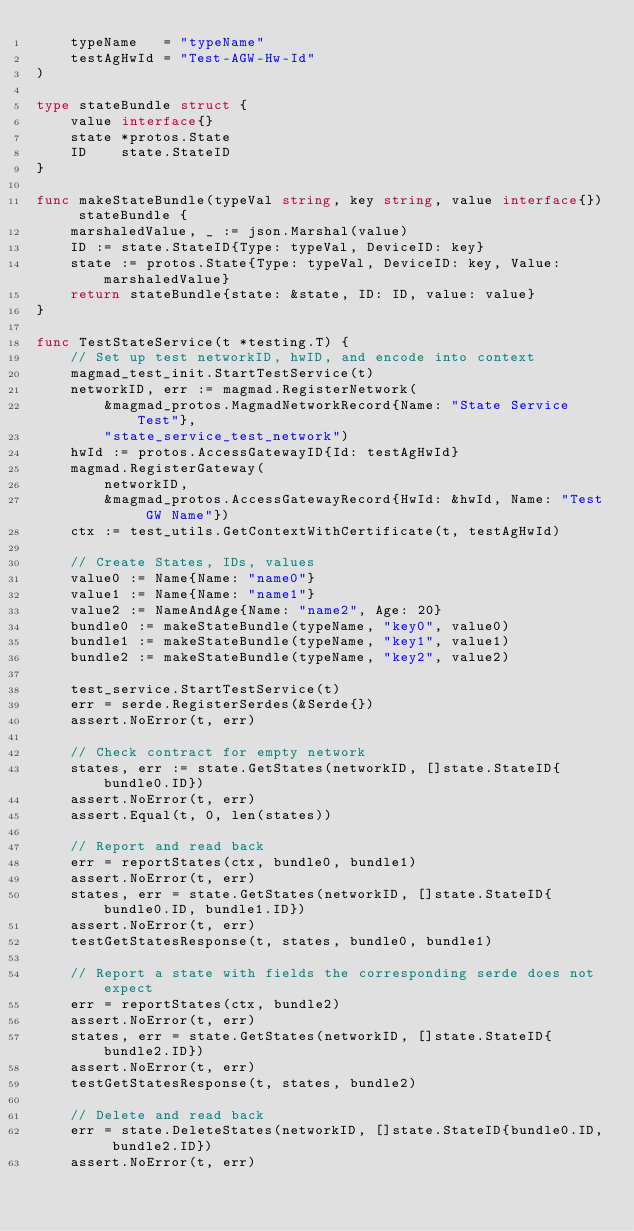<code> <loc_0><loc_0><loc_500><loc_500><_Go_>	typeName   = "typeName"
	testAgHwId = "Test-AGW-Hw-Id"
)

type stateBundle struct {
	value interface{}
	state *protos.State
	ID    state.StateID
}

func makeStateBundle(typeVal string, key string, value interface{}) stateBundle {
	marshaledValue, _ := json.Marshal(value)
	ID := state.StateID{Type: typeVal, DeviceID: key}
	state := protos.State{Type: typeVal, DeviceID: key, Value: marshaledValue}
	return stateBundle{state: &state, ID: ID, value: value}
}

func TestStateService(t *testing.T) {
	// Set up test networkID, hwID, and encode into context
	magmad_test_init.StartTestService(t)
	networkID, err := magmad.RegisterNetwork(
		&magmad_protos.MagmadNetworkRecord{Name: "State Service Test"},
		"state_service_test_network")
	hwId := protos.AccessGatewayID{Id: testAgHwId}
	magmad.RegisterGateway(
		networkID,
		&magmad_protos.AccessGatewayRecord{HwId: &hwId, Name: "Test GW Name"})
	ctx := test_utils.GetContextWithCertificate(t, testAgHwId)

	// Create States, IDs, values
	value0 := Name{Name: "name0"}
	value1 := Name{Name: "name1"}
	value2 := NameAndAge{Name: "name2", Age: 20}
	bundle0 := makeStateBundle(typeName, "key0", value0)
	bundle1 := makeStateBundle(typeName, "key1", value1)
	bundle2 := makeStateBundle(typeName, "key2", value2)

	test_service.StartTestService(t)
	err = serde.RegisterSerdes(&Serde{})
	assert.NoError(t, err)

	// Check contract for empty network
	states, err := state.GetStates(networkID, []state.StateID{bundle0.ID})
	assert.NoError(t, err)
	assert.Equal(t, 0, len(states))

	// Report and read back
	err = reportStates(ctx, bundle0, bundle1)
	assert.NoError(t, err)
	states, err = state.GetStates(networkID, []state.StateID{bundle0.ID, bundle1.ID})
	assert.NoError(t, err)
	testGetStatesResponse(t, states, bundle0, bundle1)

	// Report a state with fields the corresponding serde does not expect
	err = reportStates(ctx, bundle2)
	assert.NoError(t, err)
	states, err = state.GetStates(networkID, []state.StateID{bundle2.ID})
	assert.NoError(t, err)
	testGetStatesResponse(t, states, bundle2)

	// Delete and read back
	err = state.DeleteStates(networkID, []state.StateID{bundle0.ID, bundle2.ID})
	assert.NoError(t, err)</code> 